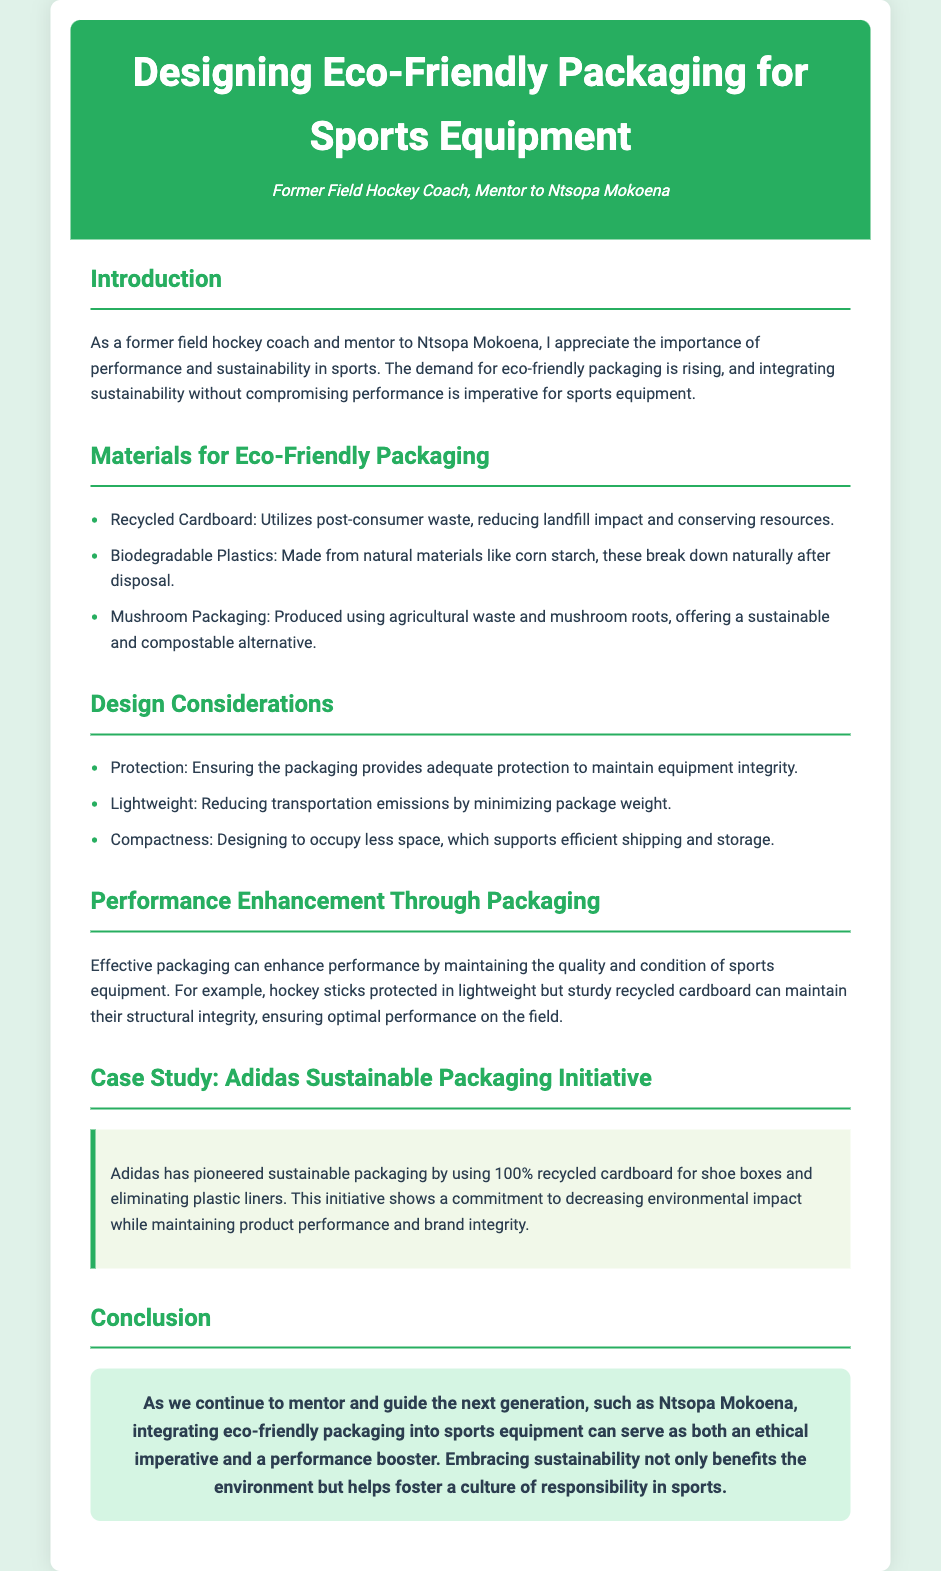What is the title of the document? The title is presented in the header section of the document.
Answer: Designing Eco-Friendly Packaging for Sports Equipment What is one material used for eco-friendly packaging? The document lists materials in the section for Eco-Friendly Packaging, providing examples.
Answer: Recycled Cardboard What design consideration is mentioned related to packaging weight? The design considerations section emphasizes lightweight packaging.
Answer: Lightweight Which company's sustainable initiative is referenced in the case study? The specific company is mentioned in the case study section of the document.
Answer: Adidas How does effective packaging enhance sports performance? The document explains that packaging can maintain quality and integrity of equipment.
Answer: Maintaining quality What type of plastic is mentioned as biodegradable? The document mentions materials in the section discussing eco-friendly options.
Answer: Biodegradable Plastics What is the main ethical benefit of integrating eco-friendly packaging according to the conclusion? The conclusion discusses the broader impact of sustainable practices in sports.
Answer: Environmental benefit Name one design consideration for improving storage efficiency. The design considerations section mentions aspects related to storing and shipping.
Answer: Compactness 